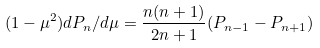<formula> <loc_0><loc_0><loc_500><loc_500>( 1 - \mu ^ { 2 } ) d P _ { n } / d \mu = \frac { n ( n + 1 ) } { 2 n + 1 } ( P _ { n - 1 } - P _ { n + 1 } )</formula> 